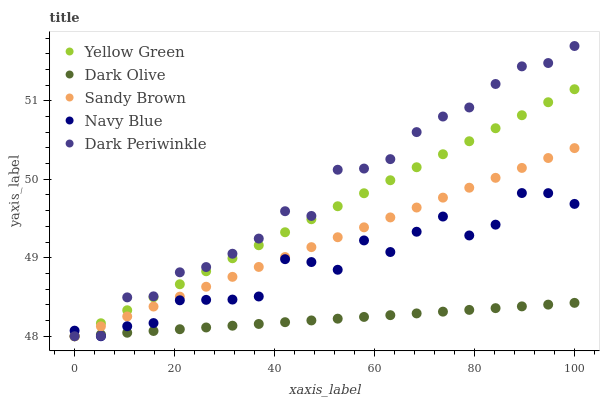Does Dark Olive have the minimum area under the curve?
Answer yes or no. Yes. Does Dark Periwinkle have the maximum area under the curve?
Answer yes or no. Yes. Does Sandy Brown have the minimum area under the curve?
Answer yes or no. No. Does Sandy Brown have the maximum area under the curve?
Answer yes or no. No. Is Dark Olive the smoothest?
Answer yes or no. Yes. Is Navy Blue the roughest?
Answer yes or no. Yes. Is Sandy Brown the smoothest?
Answer yes or no. No. Is Sandy Brown the roughest?
Answer yes or no. No. Does Navy Blue have the lowest value?
Answer yes or no. Yes. Does Dark Periwinkle have the highest value?
Answer yes or no. Yes. Does Sandy Brown have the highest value?
Answer yes or no. No. Does Dark Olive intersect Yellow Green?
Answer yes or no. Yes. Is Dark Olive less than Yellow Green?
Answer yes or no. No. Is Dark Olive greater than Yellow Green?
Answer yes or no. No. 